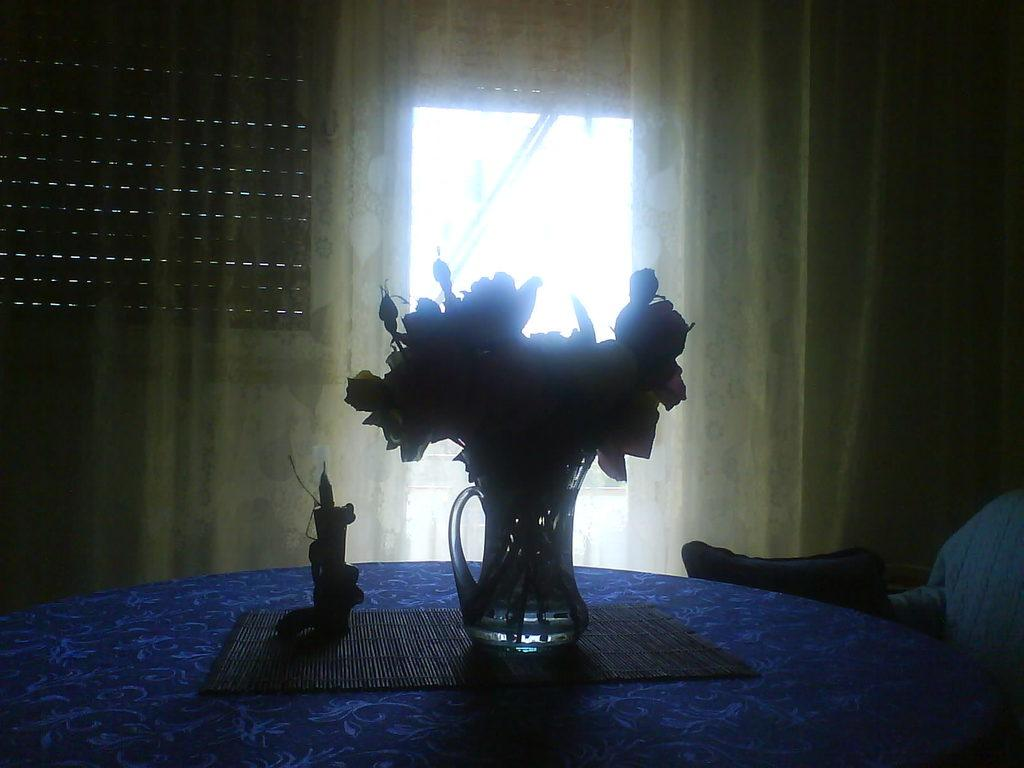What is the main piece of furniture in the image? There is a table in the image. What is placed on the table? There are decorations placed on a mat on the table. What can be seen in the background of the image? There are curtains and a window in the background of the image. What type of seating is visible in the background? There is a pillow on a chair in the background of the image. What type of cap is the building wearing in the image? There is no building present in the image, so it is not possible to determine what type of cap it might be wearing. 